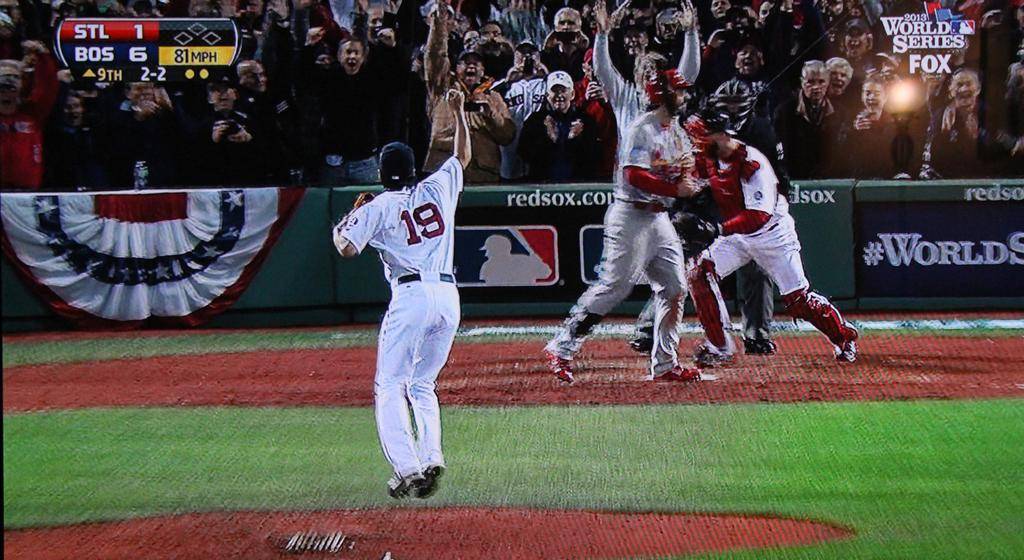<image>
Present a compact description of the photo's key features. A baseball pitcher with 19 on his shirt has just thrown an 81 MPH pitch. 